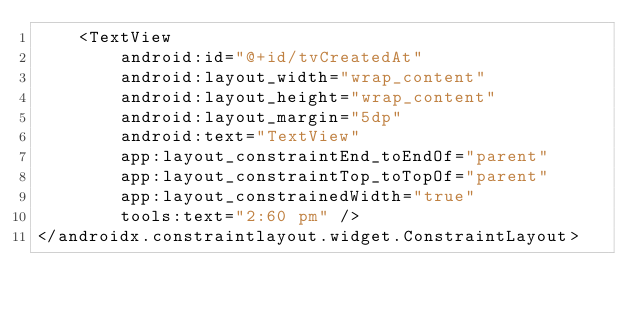<code> <loc_0><loc_0><loc_500><loc_500><_XML_>    <TextView
        android:id="@+id/tvCreatedAt"
        android:layout_width="wrap_content"
        android:layout_height="wrap_content"
        android:layout_margin="5dp"
        android:text="TextView"
        app:layout_constraintEnd_toEndOf="parent"
        app:layout_constraintTop_toTopOf="parent"
        app:layout_constrainedWidth="true"
        tools:text="2:60 pm" />
</androidx.constraintlayout.widget.ConstraintLayout></code> 